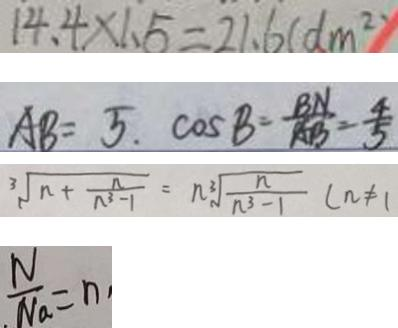<formula> <loc_0><loc_0><loc_500><loc_500>1 4 . 4 \times 1 . 5 = 2 1 . 6 ( d m ^ { 2 } ) 
 A B = 5 . \cos B = \frac { B N } { A B } = \frac { 4 } { 5 } 
 \sqrt [ 3 ] { n + \frac { n } { n ^ { 3 } - 1 } } = n \sqrt [ 3 ] { \frac { n } { n ^ { 3 } - 1 } } ( n \neq 1 
 . \frac { N } { N a } = n .</formula> 